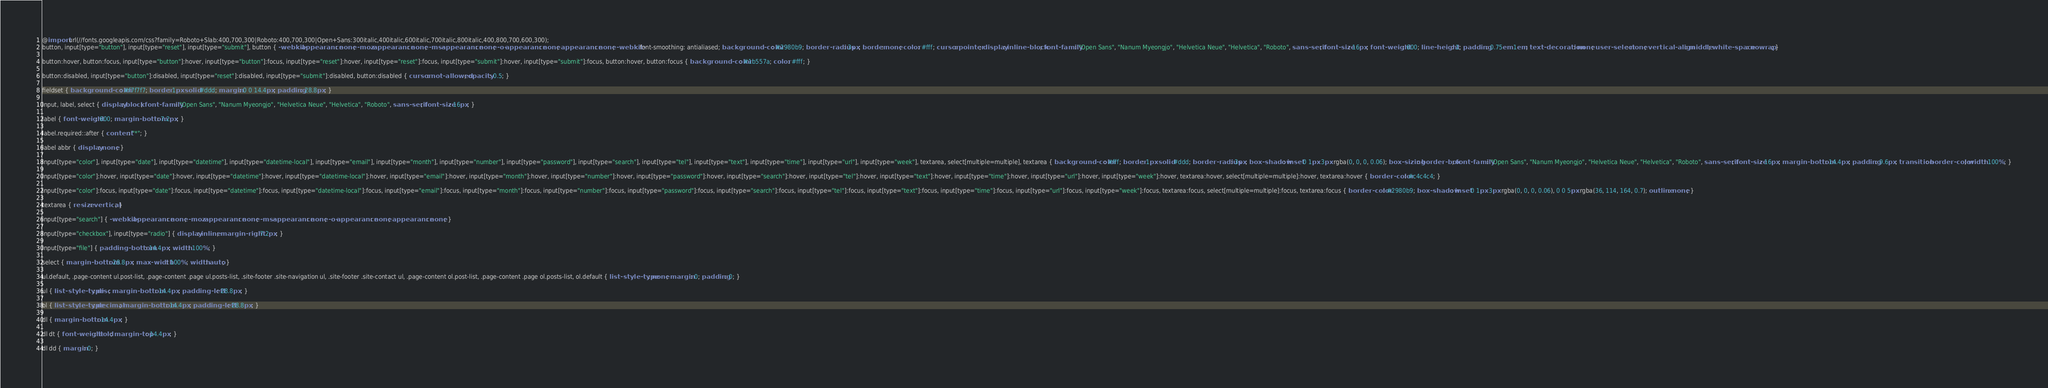<code> <loc_0><loc_0><loc_500><loc_500><_CSS_>@import url(//fonts.googleapis.com/css?family=Roboto+Slab:400,700,300|Roboto:400,700,300|Open+Sans:300italic,400italic,600italic,700italic,800italic,400,800,700,600,300);
button, input[type="button"], input[type="reset"], input[type="submit"], button { -webkit-appearance: none; -moz-appearance: none; -ms-appearance: none; -o-appearance: none; appearance: none; -webkit-font-smoothing: antialiased; background-color: #2980b9; border-radius: 3px; border: none; color: #fff; cursor: pointer; display: inline-block; font-family: "Open Sans", "Nanum Myeongjo", "Helvetica Neue", "Helvetica", "Roboto", sans-serif; font-size: 16px; font-weight: 600; line-height: 1; padding: 0.75em 1em; text-decoration: none; user-select: none; vertical-align: middle; white-space: nowrap; }

button:hover, button:focus, input[type="button"]:hover, input[type="button"]:focus, input[type="reset"]:hover, input[type="reset"]:focus, input[type="submit"]:hover, input[type="submit"]:focus, button:hover, button:focus { background-color: #1b557a; color: #fff; }

button:disabled, input[type="button"]:disabled, input[type="reset"]:disabled, input[type="submit"]:disabled, button:disabled { cursor: not-allowed; opacity: 0.5; }

fieldset { background-color: #f7f7f7; border: 1px solid #ddd; margin: 0 0 14.4px; padding: 28.8px; }

input, label, select { display: block; font-family: "Open Sans", "Nanum Myeongjo", "Helvetica Neue", "Helvetica", "Roboto", sans-serif; font-size: 16px; }

label { font-weight: 600; margin-bottom: 7.2px; }

label.required::after { content: "*"; }

label abbr { display: none; }

input[type="color"], input[type="date"], input[type="datetime"], input[type="datetime-local"], input[type="email"], input[type="month"], input[type="number"], input[type="password"], input[type="search"], input[type="tel"], input[type="text"], input[type="time"], input[type="url"], input[type="week"], textarea, select[multiple=multiple], textarea { background-color: #fff; border: 1px solid #ddd; border-radius: 3px; box-shadow: inset 0 1px 3px rgba(0, 0, 0, 0.06); box-sizing: border-box; font-family: "Open Sans", "Nanum Myeongjo", "Helvetica Neue", "Helvetica", "Roboto", sans-serif; font-size: 16px; margin-bottom: 14.4px; padding: 9.6px; transition: border-color; width: 100%; }

input[type="color"]:hover, input[type="date"]:hover, input[type="datetime"]:hover, input[type="datetime-local"]:hover, input[type="email"]:hover, input[type="month"]:hover, input[type="number"]:hover, input[type="password"]:hover, input[type="search"]:hover, input[type="tel"]:hover, input[type="text"]:hover, input[type="time"]:hover, input[type="url"]:hover, input[type="week"]:hover, textarea:hover, select[multiple=multiple]:hover, textarea:hover { border-color: #c4c4c4; }

input[type="color"]:focus, input[type="date"]:focus, input[type="datetime"]:focus, input[type="datetime-local"]:focus, input[type="email"]:focus, input[type="month"]:focus, input[type="number"]:focus, input[type="password"]:focus, input[type="search"]:focus, input[type="tel"]:focus, input[type="text"]:focus, input[type="time"]:focus, input[type="url"]:focus, input[type="week"]:focus, textarea:focus, select[multiple=multiple]:focus, textarea:focus { border-color: #2980b9; box-shadow: inset 0 1px 3px rgba(0, 0, 0, 0.06), 0 0 5px rgba(36, 114, 164, 0.7); outline: none; }

textarea { resize: vertical; }

input[type="search"] { -webkit-appearance: none; -moz-appearance: none; -ms-appearance: none; -o-appearance: none; appearance: none; }

input[type="checkbox"], input[type="radio"] { display: inline; margin-right: 7.2px; }

input[type="file"] { padding-bottom: 14.4px; width: 100%; }

select { margin-bottom: 28.8px; max-width: 100%; width: auto; }

ul.default, .page-content ul.post-list, .page-content .page ul.posts-list, .site-footer .site-navigation ul, .site-footer .site-contact ul, .page-content ol.post-list, .page-content .page ol.posts-list, ol.default { list-style-type: none; margin: 0; padding: 0; }

ul { list-style-type: disc; margin-bottom: 14.4px; padding-left: 28.8px; }

ol { list-style-type: decimal; margin-bottom: 14.4px; padding-left: 28.8px; }

dl { margin-bottom: 14.4px; }

dl dt { font-weight: bold; margin-top: 14.4px; }

dl dd { margin: 0; }
</code> 